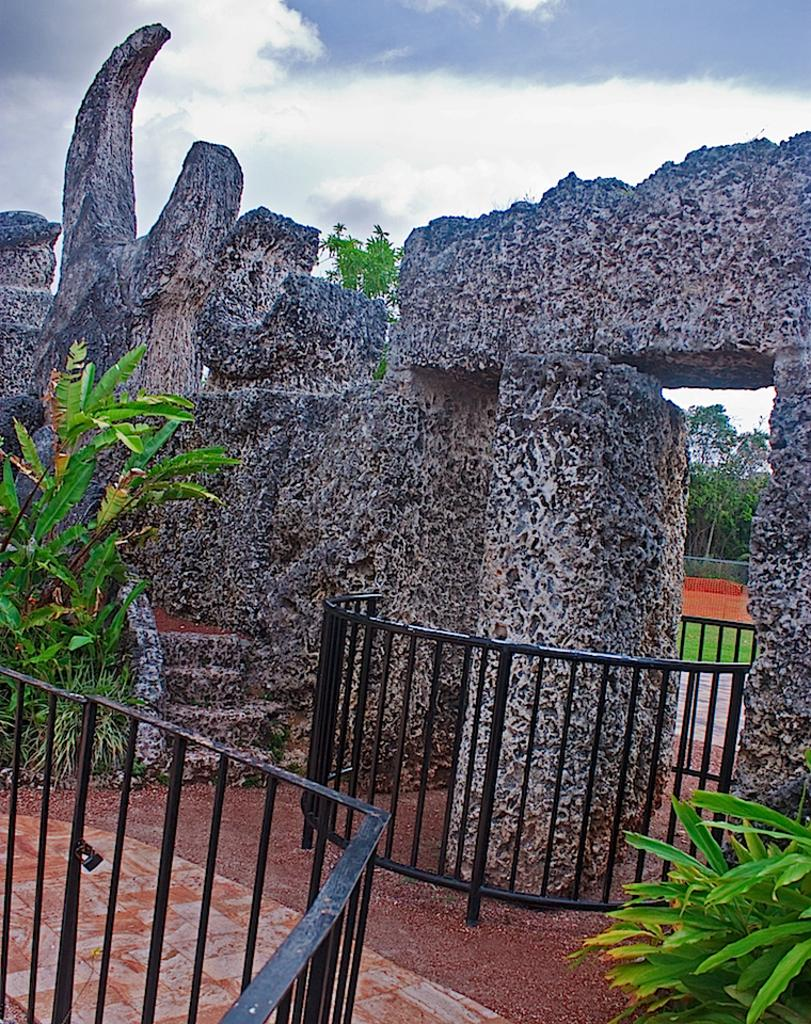What is on the ground in the image? There are fences on the ground in the image. What else can be seen in the image besides the fences? There are plants, steps, and a wall visible in the image. What is in the background of the image? There are trees and clouds in the sky in the background of the image. What type of curve can be seen in the image? There is no curve present in the image; it features fences, plants, steps, a wall, trees, and clouds. What summer experience can be observed in the image? The image does not depict a specific summer experience, as it does not show any people or activities related to summer. 